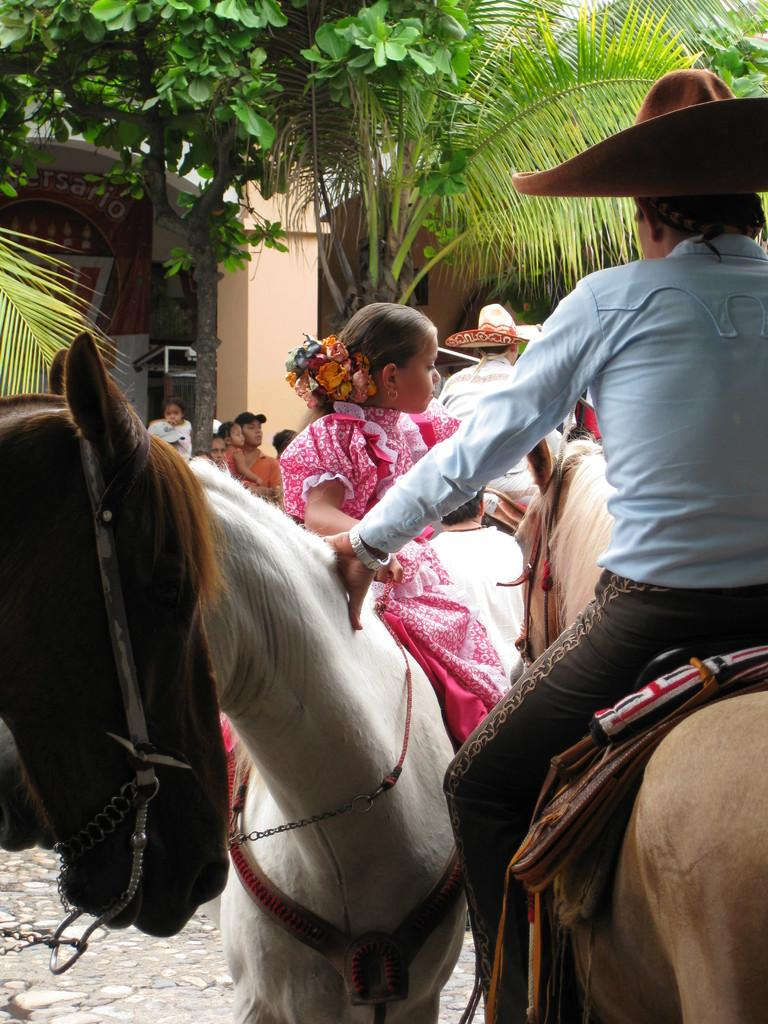What type of natural elements can be seen in the image? There are trees in the image. Who or what else is present in the image? There are people in the image. What are some of the people doing in the image? Some people are sitting on white color horses. What type of string is being used to develop the interest of the horses in the image? There is no mention of string, development, or interest in the image; it simply shows people sitting on white color horses. 